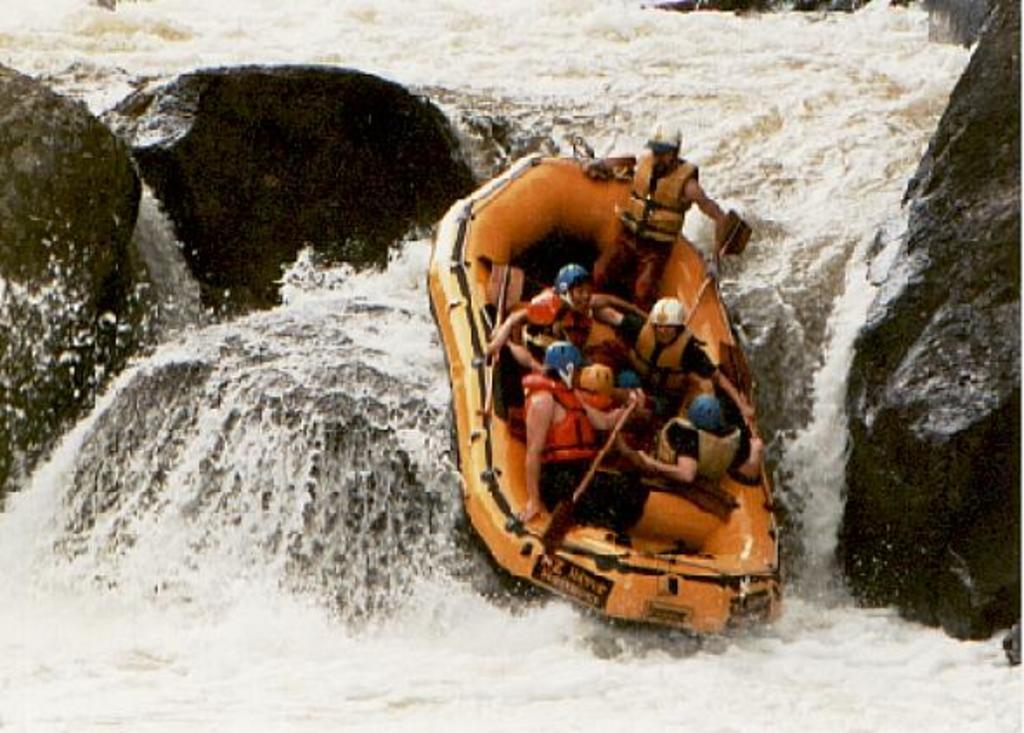How would you summarize this image in a sentence or two? In this image I can see a orange color boat visible on the lake , on the lake I can see stones and in the boat I can see persons wearing a helmet and sitting on that. 